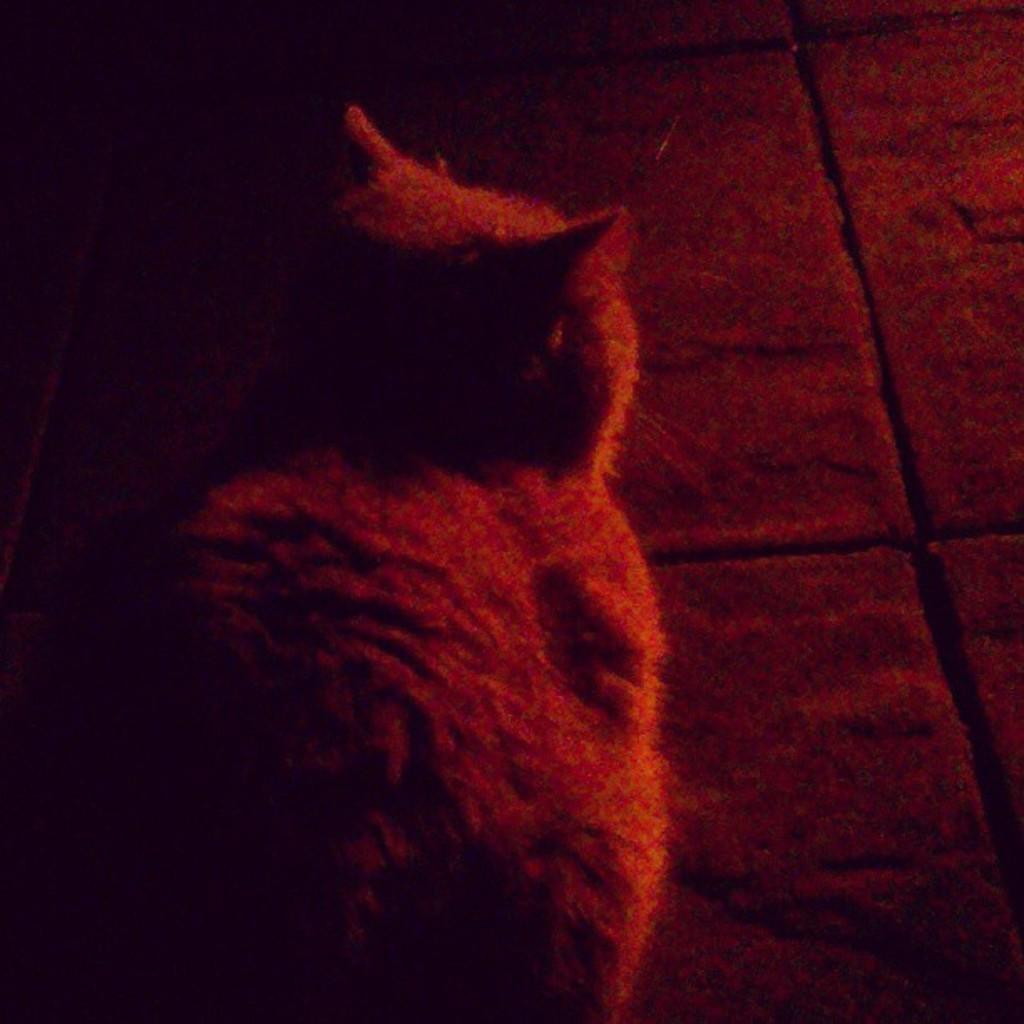What is the main subject in the middle of the picture? There is an animal in the middle of the picture. What can be seen in the background of the picture? There is a floor visible in the background of the picture. What type of plantation can be seen in the background of the image? There is no plantation present in the image; it only features an animal and a floor in the background. How many twigs are visible in the image? There is no mention of twigs in the image, so it is not possible to determine their presence or quantity. 